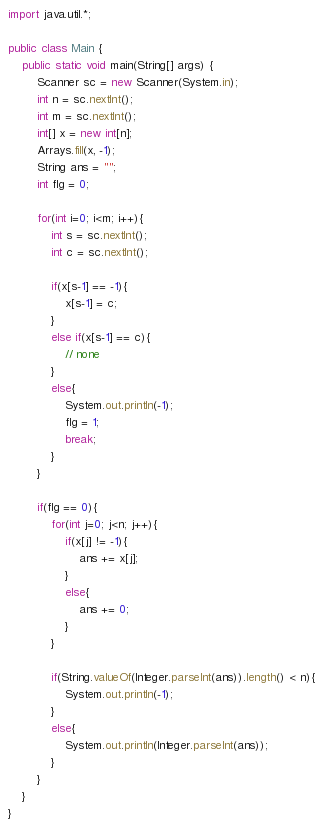<code> <loc_0><loc_0><loc_500><loc_500><_Java_>import java.util.*;

public class Main {
    public static void main(String[] args) {
        Scanner sc = new Scanner(System.in);
        int n = sc.nextInt();
        int m = sc.nextInt();
        int[] x = new int[n];
        Arrays.fill(x, -1);
        String ans = "";
        int flg = 0;
        
        for(int i=0; i<m; i++){
            int s = sc.nextInt();
            int c = sc.nextInt();
            
            if(x[s-1] == -1){
                x[s-1] = c;
            }
            else if(x[s-1] == c){
                // none
            }
            else{
                System.out.println(-1);
                flg = 1;
                break;
            }
        }
        
        if(flg == 0){
            for(int j=0; j<n; j++){
                if(x[j] != -1){
                    ans += x[j];
                }
                else{
                    ans += 0;
                }
            }
            
            if(String.valueOf(Integer.parseInt(ans)).length() < n){
                System.out.println(-1);
            }
            else{
                System.out.println(Integer.parseInt(ans));
            }
        }
    }
}</code> 